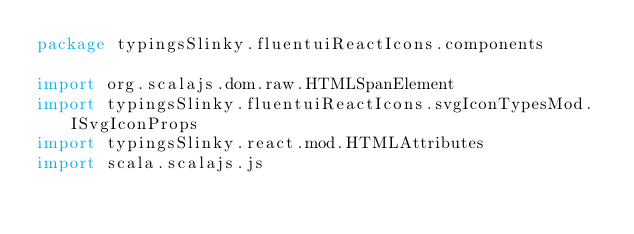<code> <loc_0><loc_0><loc_500><loc_500><_Scala_>package typingsSlinky.fluentuiReactIcons.components

import org.scalajs.dom.raw.HTMLSpanElement
import typingsSlinky.fluentuiReactIcons.svgIconTypesMod.ISvgIconProps
import typingsSlinky.react.mod.HTMLAttributes
import scala.scalajs.js</code> 